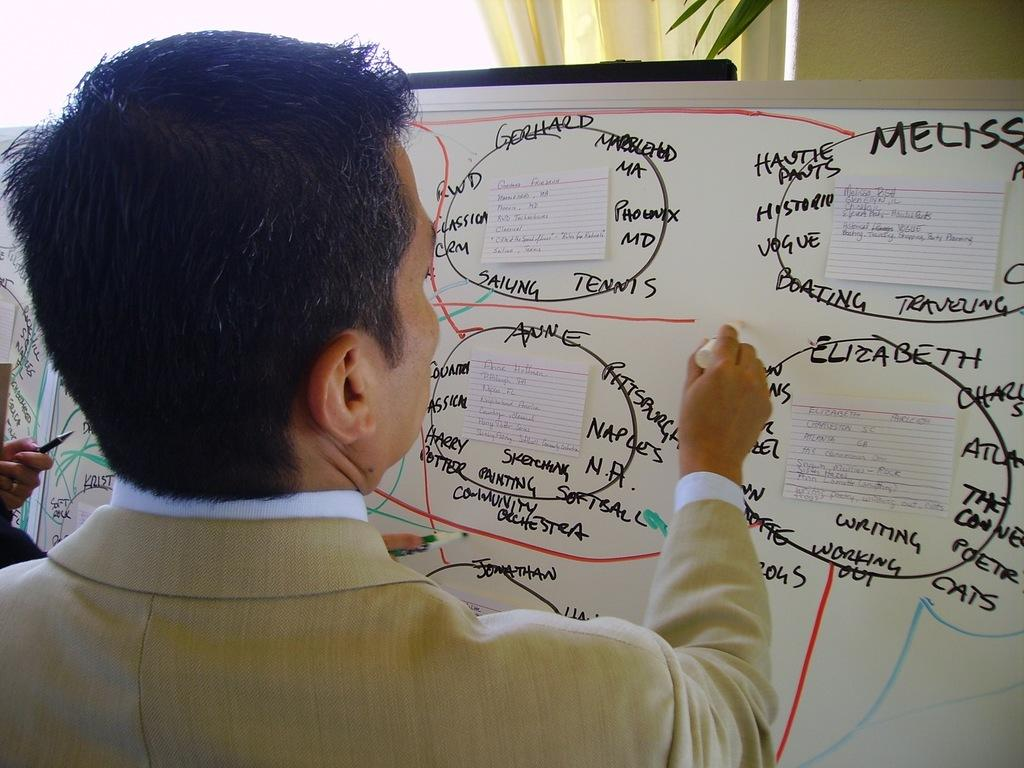<image>
Present a compact description of the photo's key features. the name Elizabeth is on the white board indoors 